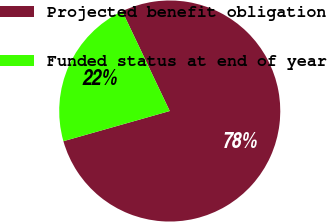Convert chart. <chart><loc_0><loc_0><loc_500><loc_500><pie_chart><fcel>Projected benefit obligation<fcel>Funded status at end of year<nl><fcel>77.67%<fcel>22.33%<nl></chart> 